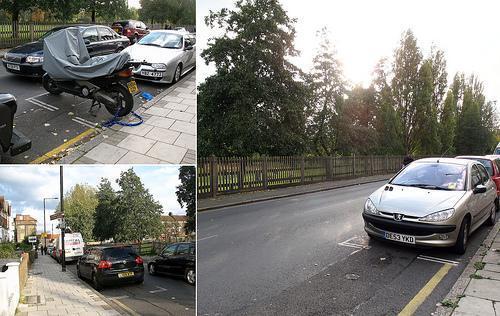How many pictures are there?
Give a very brief answer. 3. 